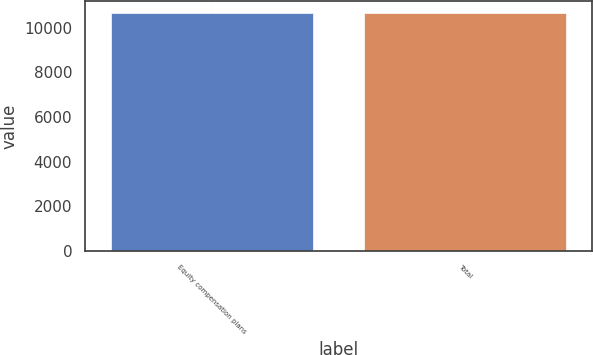Convert chart. <chart><loc_0><loc_0><loc_500><loc_500><bar_chart><fcel>Equity compensation plans<fcel>Total<nl><fcel>10650<fcel>10650.1<nl></chart> 